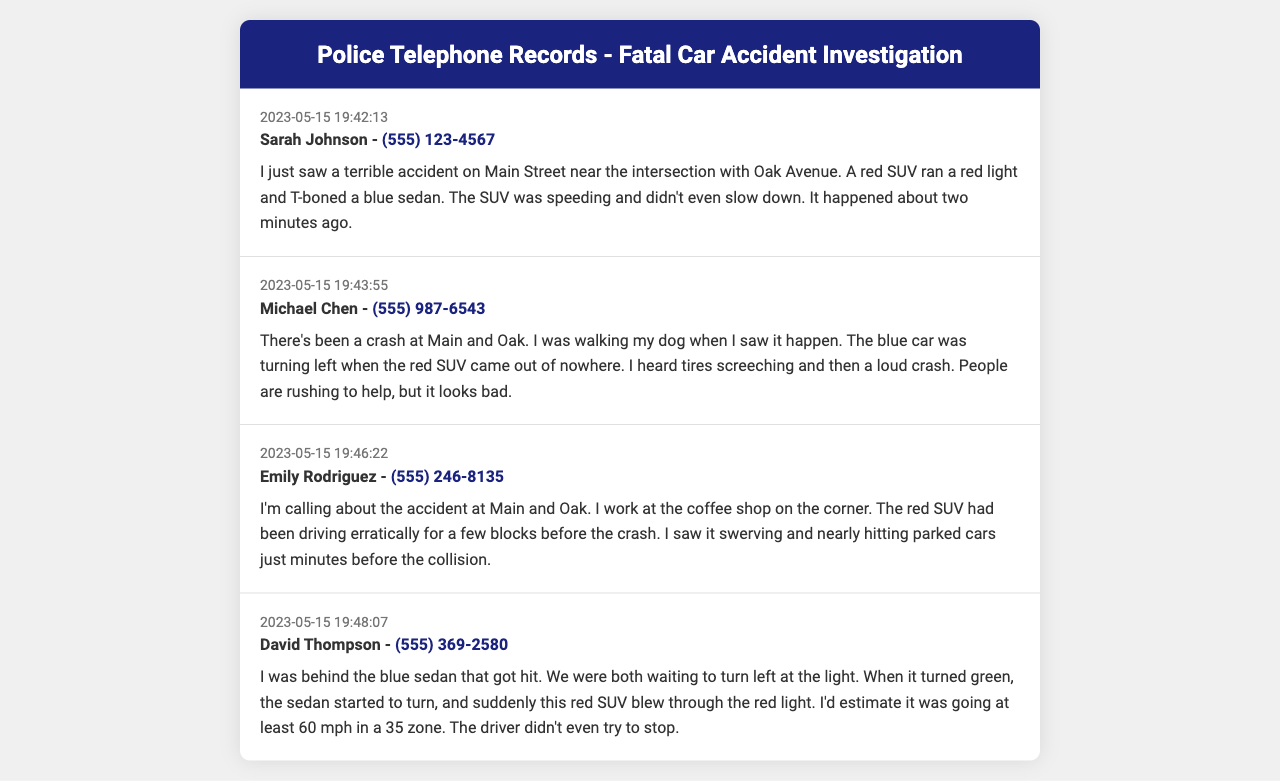What time did Sarah Johnson report the accident? The document provides the timestamp of her call as 2023-05-15 19:42:13.
Answer: 2023-05-15 19:42:13 What was the color of the SUV involved in the accident? The transcript from Sarah Johnson describes the SUV as red.
Answer: red What observation did Emily Rodriguez make about the SUV before the crash? Emily indicated that the red SUV had been driving erratically and swerving just minutes prior to the collision.
Answer: driving erratically How fast did David Thompson estimate the red SUV was going? The document states that David estimated the SUV was going at least 60 mph in a 35 zone.
Answer: at least 60 mph Which intersection was the accident reported at? Multiple witnesses noted that the accident occurred at Main and Oak.
Answer: Main and Oak How many witnesses provided their accounts in the records? The document contains four distinct records from witnesses who provided details about the accident.
Answer: four What did Michael Chen hear just before the crash? Michael described hearing tires screeching followed by a loud crash right before the accident occurred.
Answer: tires screeching What was the condition of the blue sedan according to David Thompson? David noted that the blue sedan was waiting to turn left when the accident occurred.
Answer: waiting to turn left What is the phone number of Sarah Johnson? The document lists her phone number as (555) 123-4567.
Answer: (555) 123-4567 